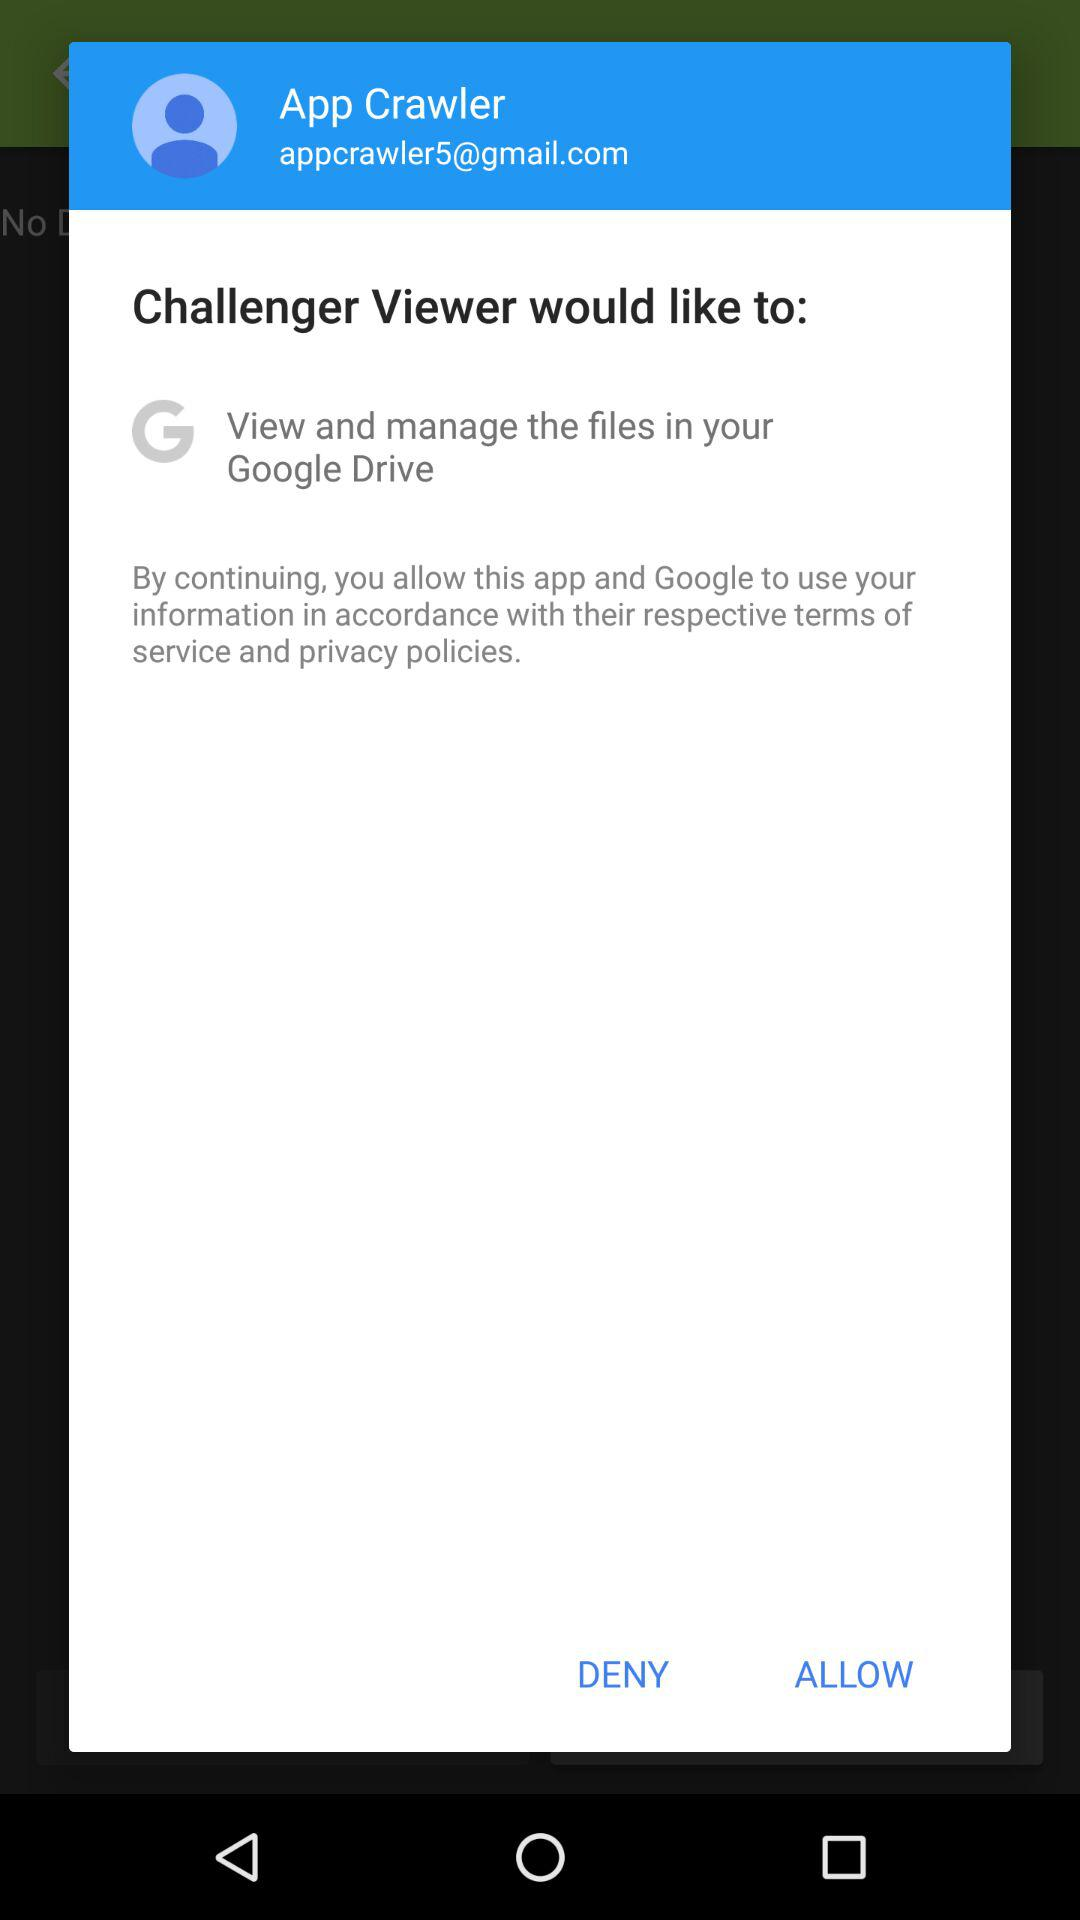How many actions can the user take to proceed?
Answer the question using a single word or phrase. 2 